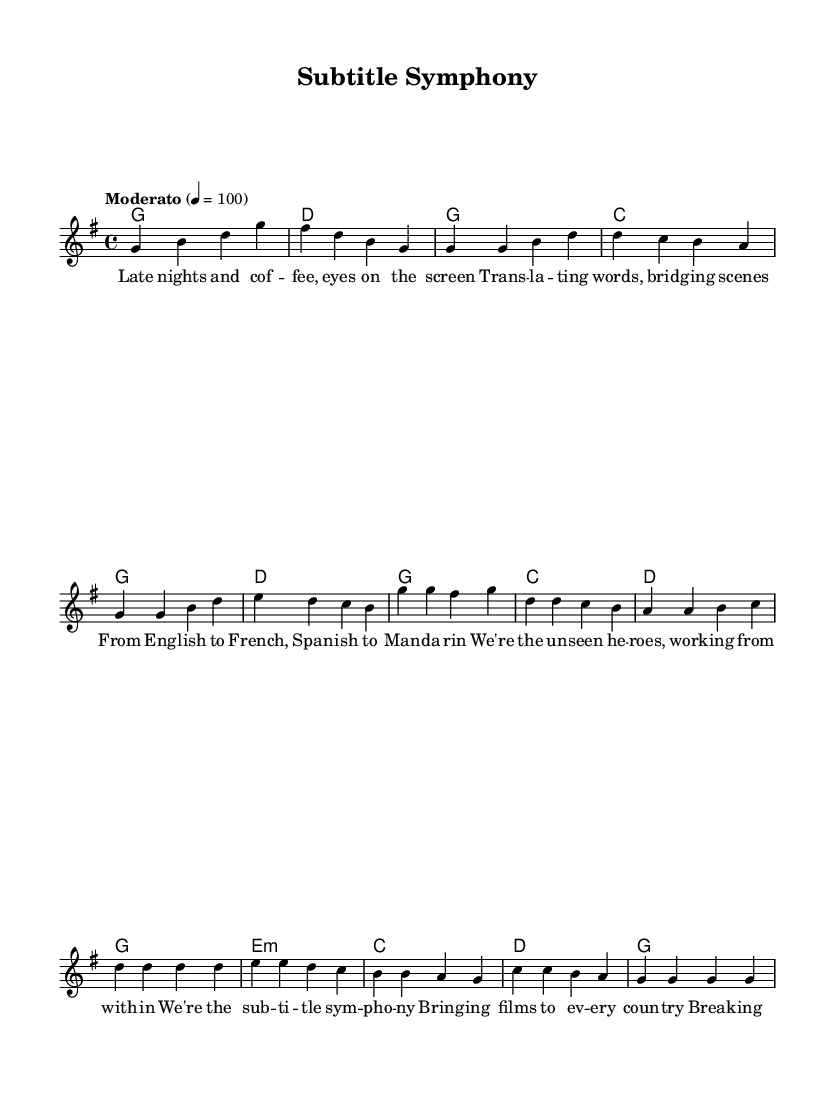What is the key signature of this music? The key signature is G major, which has one sharp (F sharp). This can be identified by observing the key signature indicated at the beginning of the score.
Answer: G major What is the time signature of this piece? The time signature is 4/4, which means there are four beats in each measure and a quarter note gets one beat. This is indicated at the beginning of the score before the first measure.
Answer: 4/4 What is the tempo marking for this piece? The tempo marking is Moderato, which typically means a moderate pace. This can be found written above the score after the time signature indicating how the music should be played.
Answer: Moderato How many measures are in the chorus section? The chorus section consists of four measures. This can be determined by counting the measures in the section labeled as "Chorus" within the score.
Answer: Four What harmony is used in the bridge section? The harmony used in the bridge section is E minor. The notation marked with 'm' after E indicates that it is in minor key. This can be deduced from the chord mode beneath the melody.
Answer: E minor How many lines are in the first verse? The first verse has four lines of lyrics. This can be seen by counting the distinct lyric lines that are part of the verse section labeled as "Verse."
Answer: Four What is the theme of the song based on the lyrics? The theme of the song revolves around translation and the role of subtitle translators in making films accessible across languages. This can be inferred from the lyrics discussing late nights, translating, and being unseen heroes.
Answer: Subtitle translation 